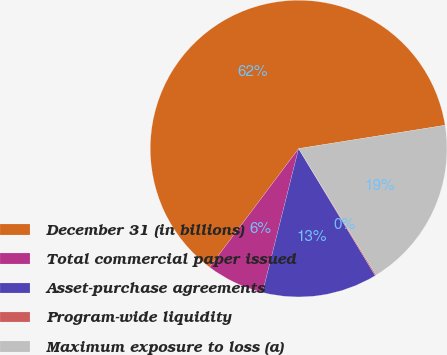Convert chart to OTSL. <chart><loc_0><loc_0><loc_500><loc_500><pie_chart><fcel>December 31 (in billions)<fcel>Total commercial paper issued<fcel>Asset-purchase agreements<fcel>Program-wide liquidity<fcel>Maximum exposure to loss (a)<nl><fcel>62.24%<fcel>6.34%<fcel>12.55%<fcel>0.12%<fcel>18.76%<nl></chart> 